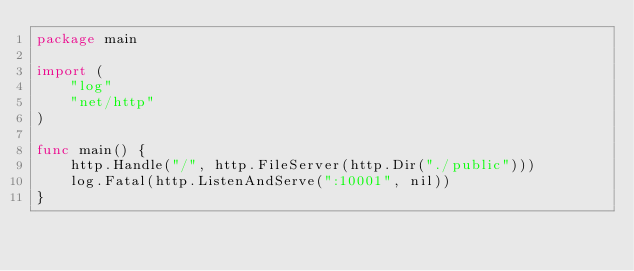<code> <loc_0><loc_0><loc_500><loc_500><_Go_>package main

import (
	"log"
	"net/http"
)

func main() {
	http.Handle("/", http.FileServer(http.Dir("./public")))
	log.Fatal(http.ListenAndServe(":10001", nil))
}
</code> 